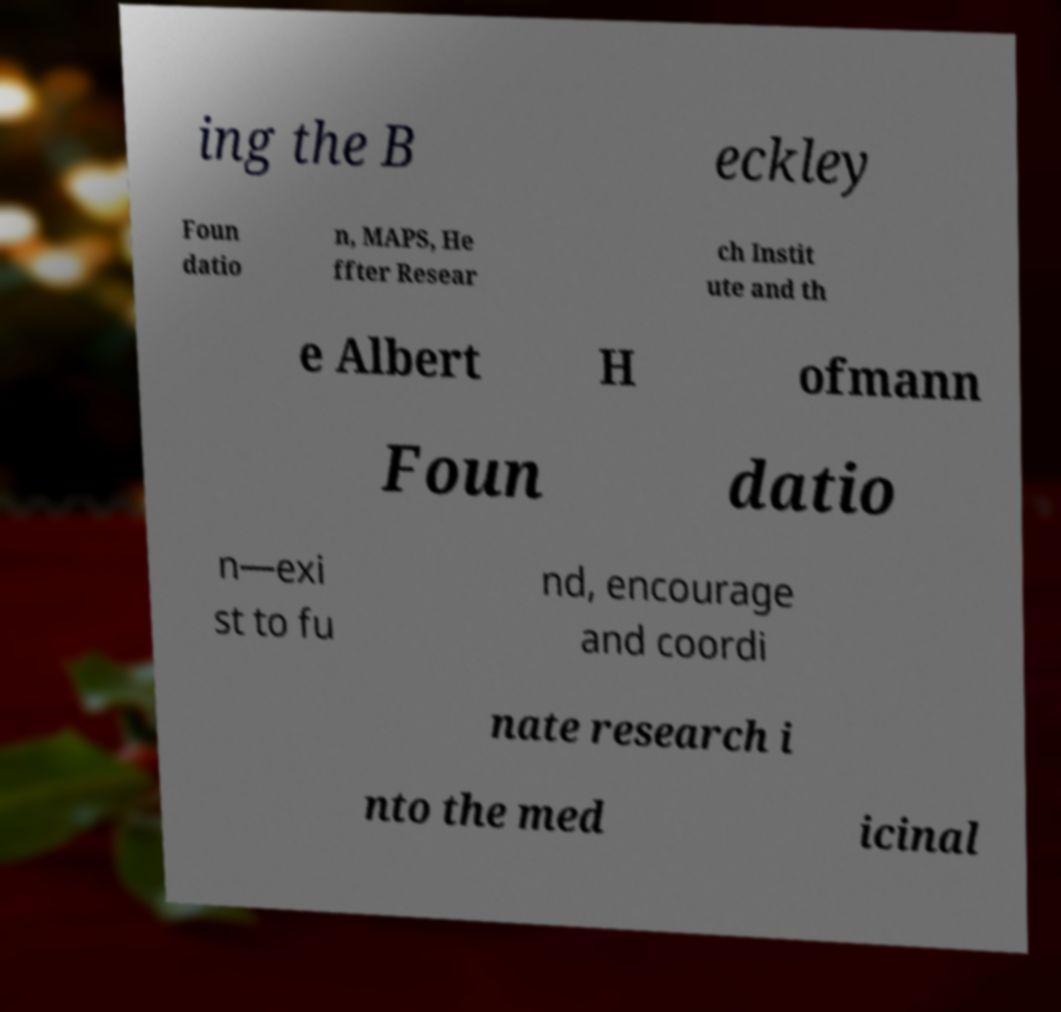Please read and relay the text visible in this image. What does it say? ing the B eckley Foun datio n, MAPS, He ffter Resear ch Instit ute and th e Albert H ofmann Foun datio n—exi st to fu nd, encourage and coordi nate research i nto the med icinal 